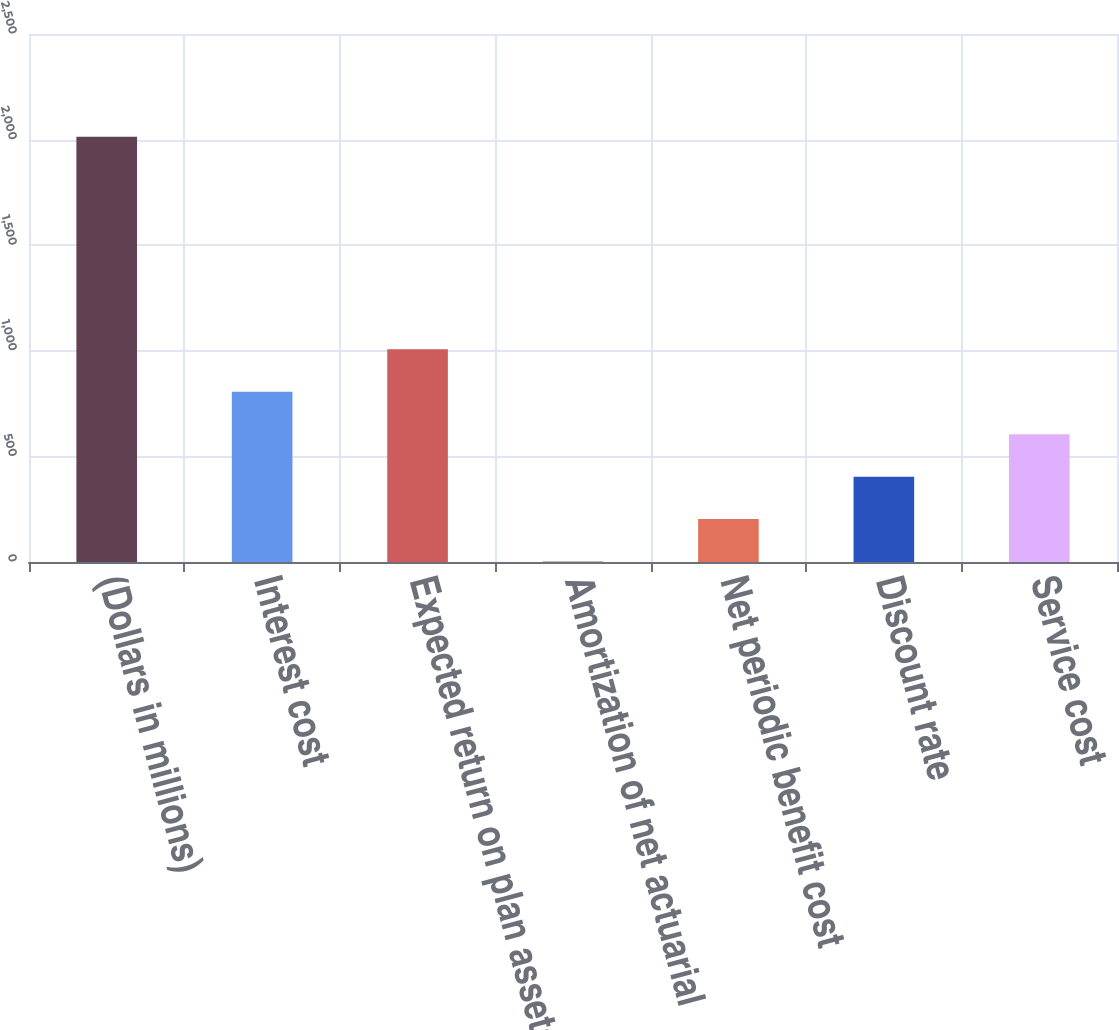Convert chart to OTSL. <chart><loc_0><loc_0><loc_500><loc_500><bar_chart><fcel>(Dollars in millions)<fcel>Interest cost<fcel>Expected return on plan assets<fcel>Amortization of net actuarial<fcel>Net periodic benefit cost<fcel>Discount rate<fcel>Service cost<nl><fcel>2013<fcel>806.4<fcel>1007.5<fcel>2<fcel>203.1<fcel>404.2<fcel>605.3<nl></chart> 